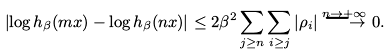Convert formula to latex. <formula><loc_0><loc_0><loc_500><loc_500>\left | \log h _ { \beta } ( m x ) - \log h _ { \beta } ( n x ) \right | \leq 2 \beta ^ { 2 } \sum _ { j \geq n } \sum _ { i \geq j } | \rho _ { i } | \stackrel { n \rightarrow + \infty } { \longrightarrow } 0 .</formula> 